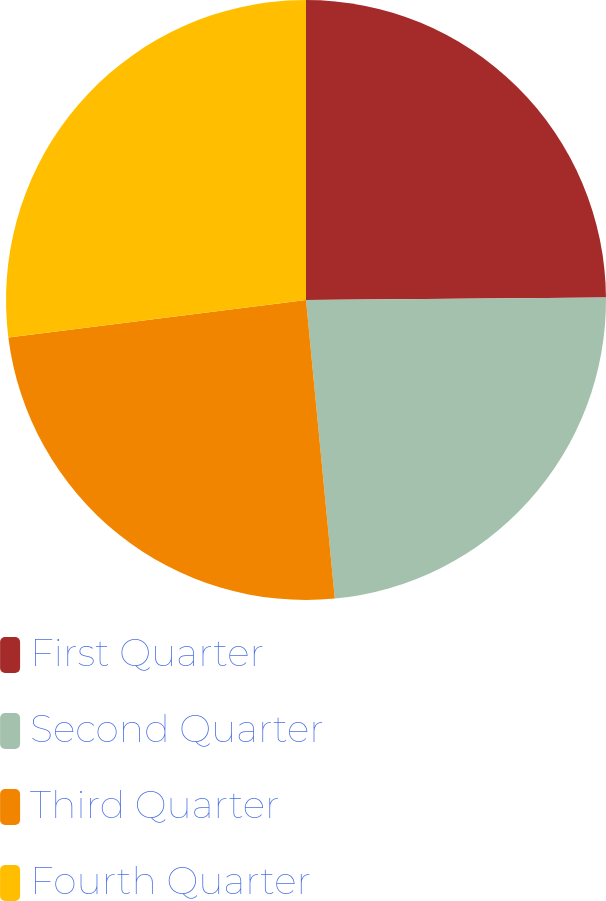Convert chart. <chart><loc_0><loc_0><loc_500><loc_500><pie_chart><fcel>First Quarter<fcel>Second Quarter<fcel>Third Quarter<fcel>Fourth Quarter<nl><fcel>24.87%<fcel>23.6%<fcel>24.54%<fcel>26.99%<nl></chart> 